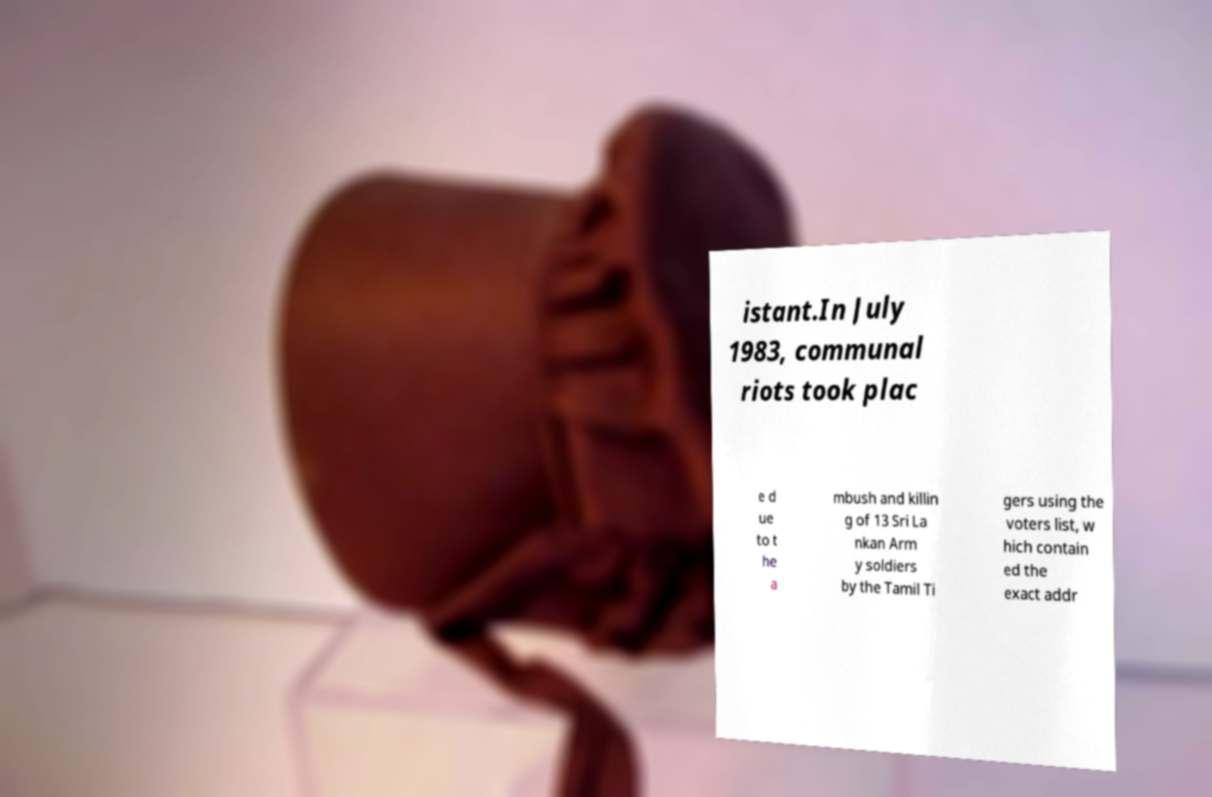Please identify and transcribe the text found in this image. istant.In July 1983, communal riots took plac e d ue to t he a mbush and killin g of 13 Sri La nkan Arm y soldiers by the Tamil Ti gers using the voters list, w hich contain ed the exact addr 